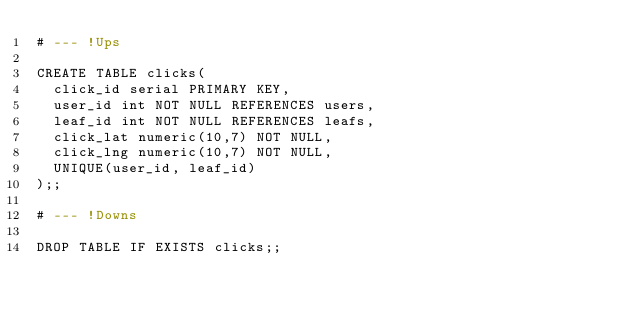<code> <loc_0><loc_0><loc_500><loc_500><_SQL_># --- !Ups

CREATE TABLE clicks(
	click_id serial PRIMARY KEY,
  user_id int NOT NULL REFERENCES users,
  leaf_id int NOT NULL REFERENCES leafs,
  click_lat numeric(10,7) NOT NULL,
  click_lng numeric(10,7) NOT NULL,
  UNIQUE(user_id, leaf_id)
);;

# --- !Downs

DROP TABLE IF EXISTS clicks;;
</code> 